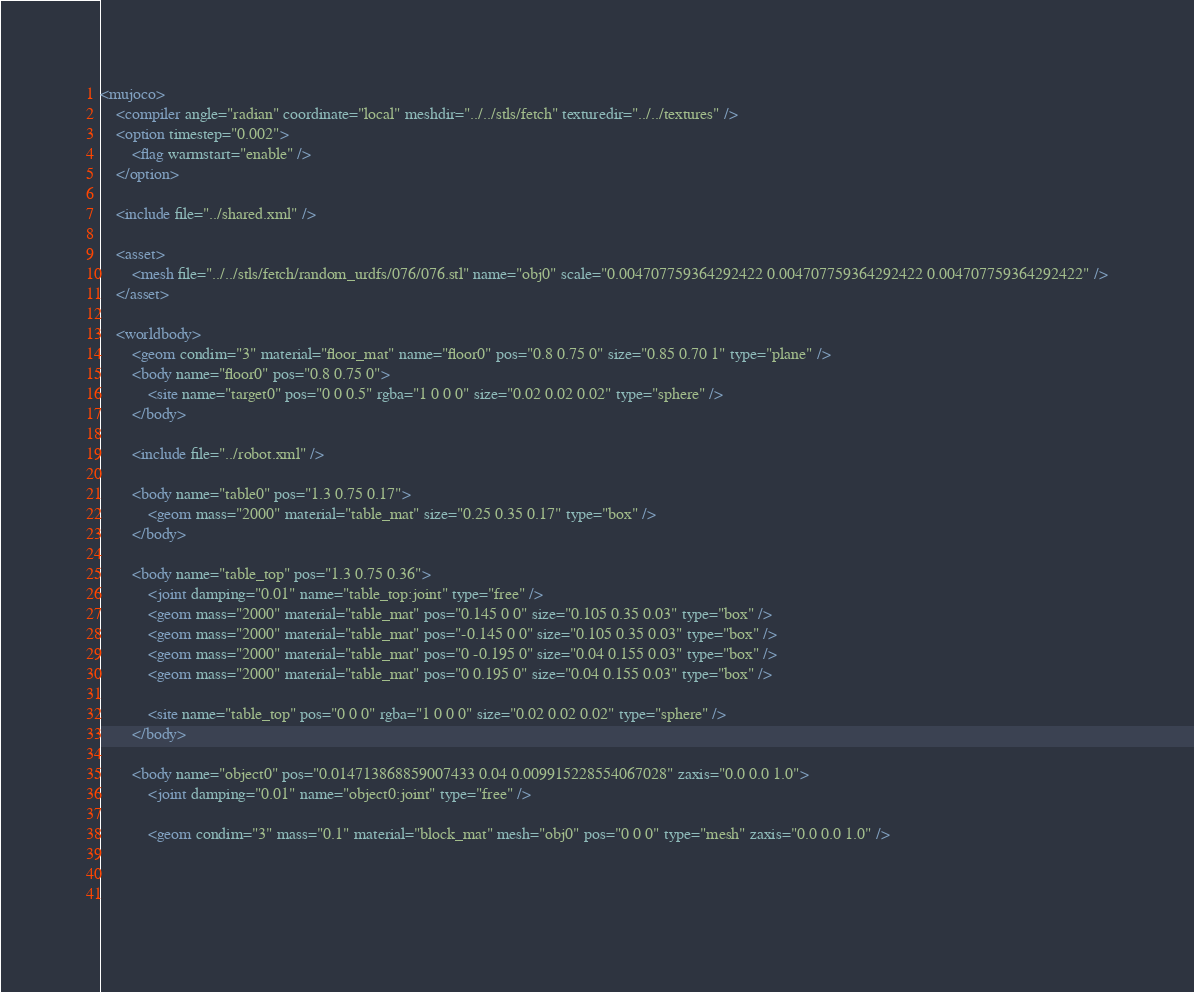Convert code to text. <code><loc_0><loc_0><loc_500><loc_500><_XML_><mujoco>
	<compiler angle="radian" coordinate="local" meshdir="../../stls/fetch" texturedir="../../textures" />
	<option timestep="0.002">
		<flag warmstart="enable" />
	</option>

	<include file="../shared.xml" />

	<asset>
		<mesh file="../../stls/fetch/random_urdfs/076/076.stl" name="obj0" scale="0.004707759364292422 0.004707759364292422 0.004707759364292422" />
	</asset>

	<worldbody>
		<geom condim="3" material="floor_mat" name="floor0" pos="0.8 0.75 0" size="0.85 0.70 1" type="plane" />
		<body name="floor0" pos="0.8 0.75 0">
			<site name="target0" pos="0 0 0.5" rgba="1 0 0 0" size="0.02 0.02 0.02" type="sphere" />
		</body>

		<include file="../robot.xml" />

		<body name="table0" pos="1.3 0.75 0.17">
			<geom mass="2000" material="table_mat" size="0.25 0.35 0.17" type="box" />
		</body>

		<body name="table_top" pos="1.3 0.75 0.36">
			<joint damping="0.01" name="table_top:joint" type="free" />
			<geom mass="2000" material="table_mat" pos="0.145 0 0" size="0.105 0.35 0.03" type="box" />
			<geom mass="2000" material="table_mat" pos="-0.145 0 0" size="0.105 0.35 0.03" type="box" />
			<geom mass="2000" material="table_mat" pos="0 -0.195 0" size="0.04 0.155 0.03" type="box" />
			<geom mass="2000" material="table_mat" pos="0 0.195 0" size="0.04 0.155 0.03" type="box" />

			<site name="table_top" pos="0 0 0" rgba="1 0 0 0" size="0.02 0.02 0.02" type="sphere" />
		</body>

		<body name="object0" pos="0.014713868859007433 0.04 0.009915228554067028" zaxis="0.0 0.0 1.0">
			<joint damping="0.01" name="object0:joint" type="free" />
			
			<geom condim="3" mass="0.1" material="block_mat" mesh="obj0" pos="0 0 0" type="mesh" zaxis="0.0 0.0 1.0" />
			
			
			</code> 